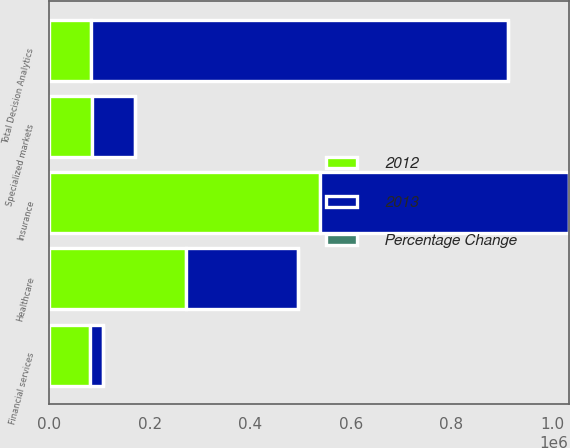Convert chart to OTSL. <chart><loc_0><loc_0><loc_500><loc_500><stacked_bar_chart><ecel><fcel>Insurance<fcel>Financial services<fcel>Healthcare<fcel>Specialized markets<fcel>Total Decision Analytics<nl><fcel>2012<fcel>539150<fcel>81113<fcel>271538<fcel>85626<fcel>83238.5<nl><fcel>2013<fcel>493456<fcel>26567<fcel>222955<fcel>85364<fcel>828342<nl><fcel>Percentage Change<fcel>9.3<fcel>205.3<fcel>21.8<fcel>0.3<fcel>18<nl></chart> 